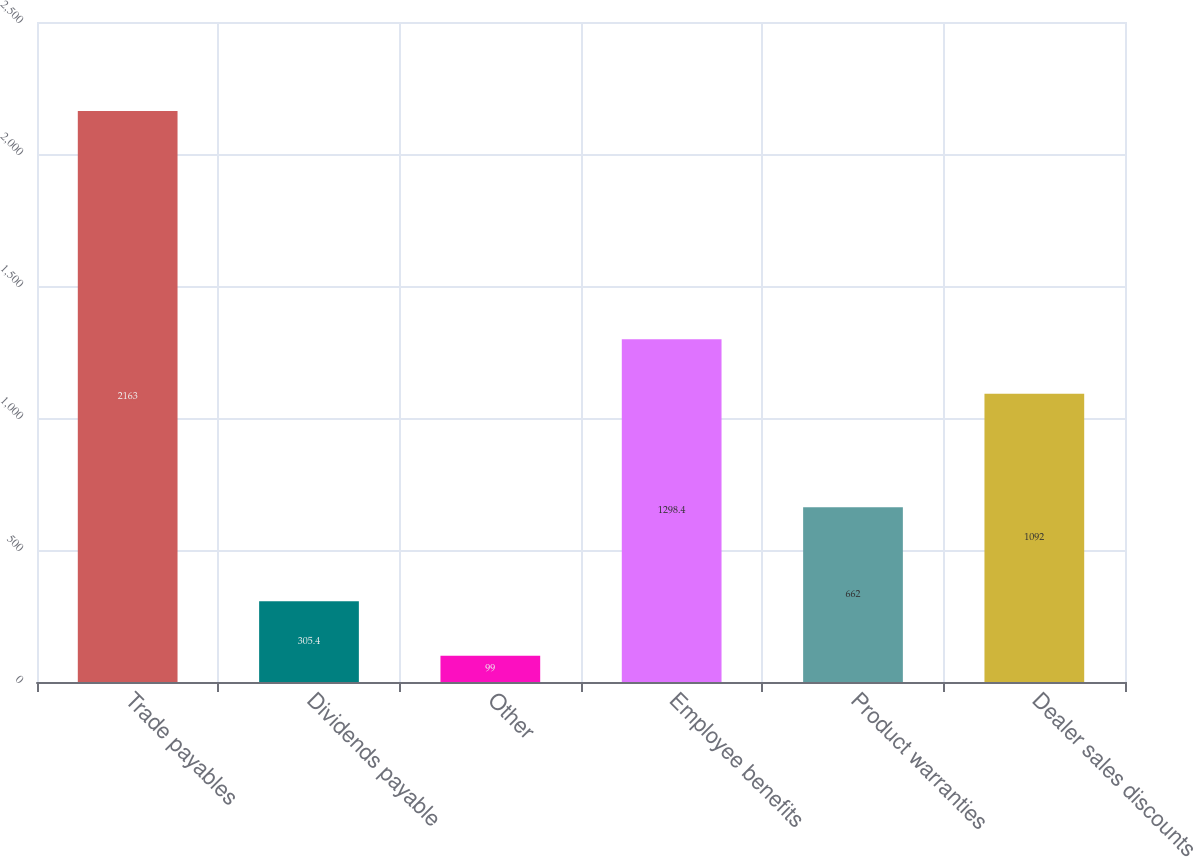<chart> <loc_0><loc_0><loc_500><loc_500><bar_chart><fcel>Trade payables<fcel>Dividends payable<fcel>Other<fcel>Employee benefits<fcel>Product warranties<fcel>Dealer sales discounts<nl><fcel>2163<fcel>305.4<fcel>99<fcel>1298.4<fcel>662<fcel>1092<nl></chart> 